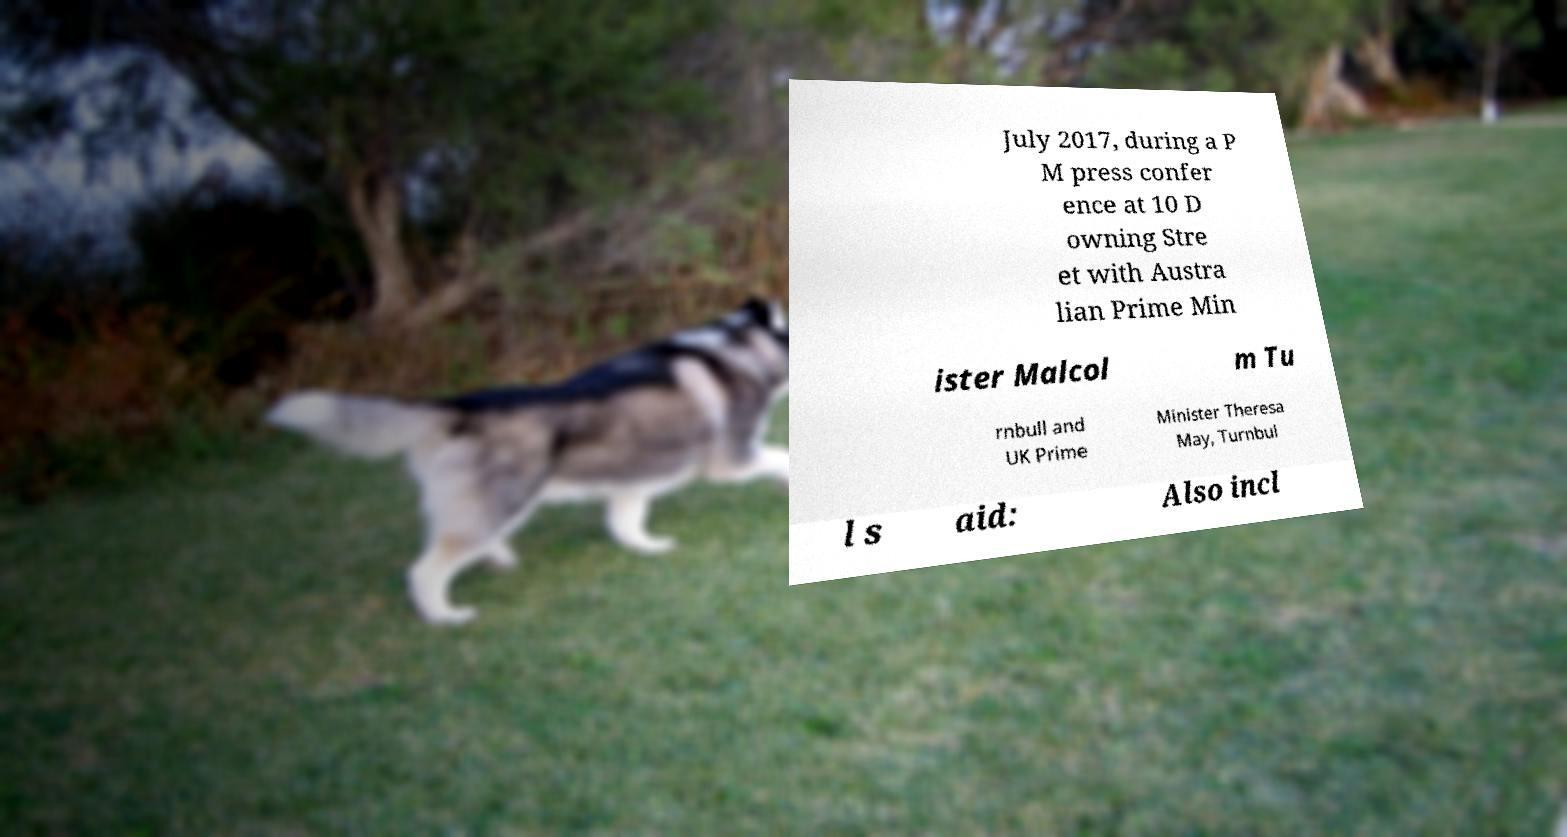I need the written content from this picture converted into text. Can you do that? July 2017, during a P M press confer ence at 10 D owning Stre et with Austra lian Prime Min ister Malcol m Tu rnbull and UK Prime Minister Theresa May, Turnbul l s aid: Also incl 